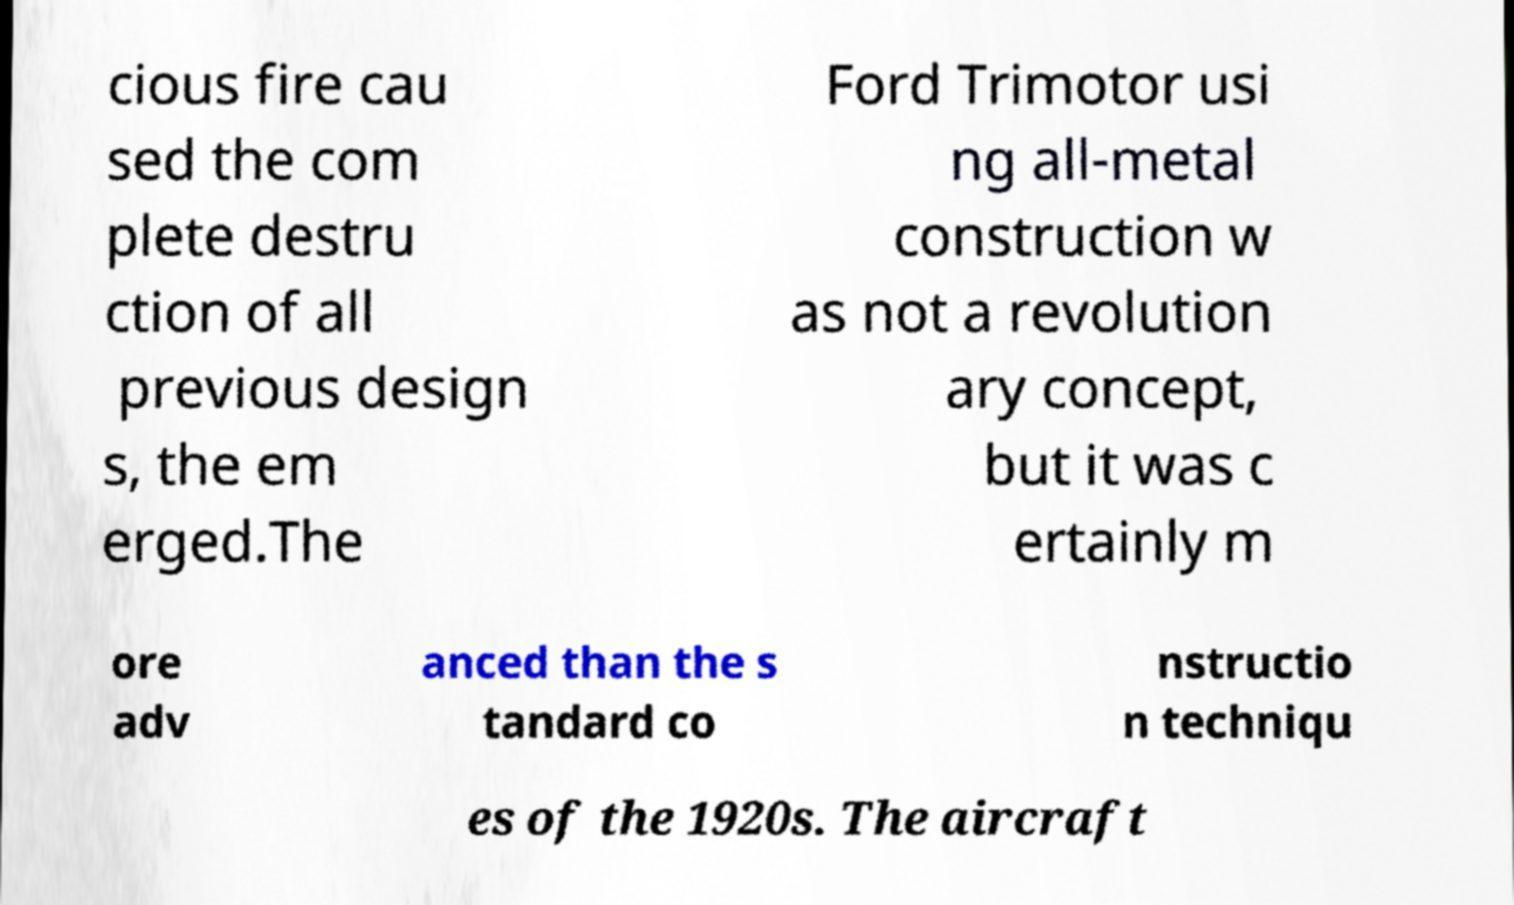What messages or text are displayed in this image? I need them in a readable, typed format. cious fire cau sed the com plete destru ction of all previous design s, the em erged.The Ford Trimotor usi ng all-metal construction w as not a revolution ary concept, but it was c ertainly m ore adv anced than the s tandard co nstructio n techniqu es of the 1920s. The aircraft 